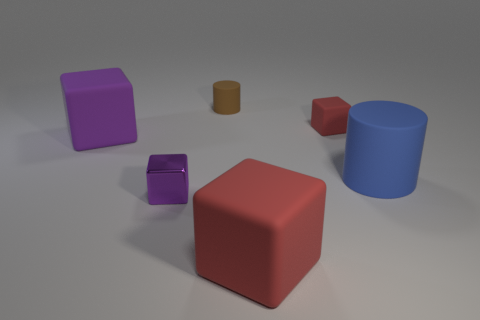How many red cubes must be subtracted to get 1 red cubes? 1 Add 1 small matte objects. How many objects exist? 7 Subtract all small purple shiny cubes. How many cubes are left? 3 Subtract 1 cylinders. How many cylinders are left? 1 Subtract all red blocks. How many blocks are left? 2 Subtract all yellow balls. How many cyan cylinders are left? 0 Add 4 blue matte objects. How many blue matte objects exist? 5 Subtract 0 green cylinders. How many objects are left? 6 Subtract all blocks. How many objects are left? 2 Subtract all green blocks. Subtract all cyan balls. How many blocks are left? 4 